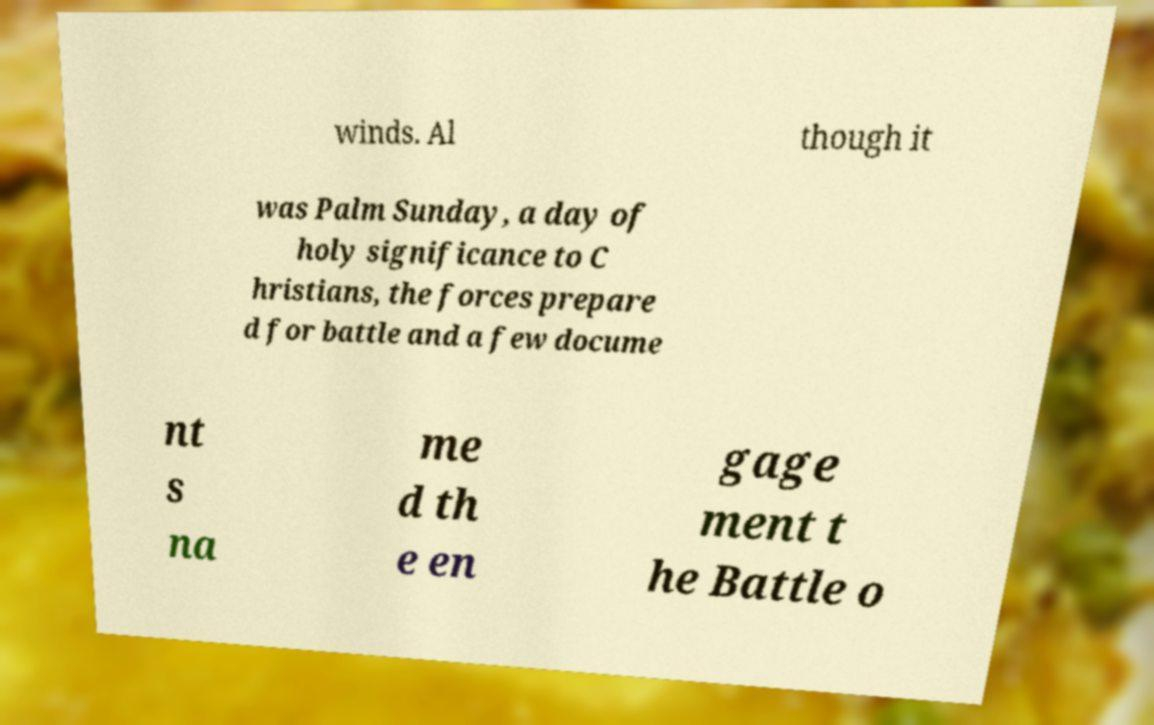I need the written content from this picture converted into text. Can you do that? winds. Al though it was Palm Sunday, a day of holy significance to C hristians, the forces prepare d for battle and a few docume nt s na me d th e en gage ment t he Battle o 